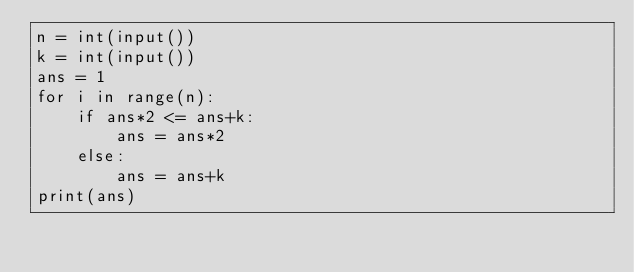<code> <loc_0><loc_0><loc_500><loc_500><_Python_>n = int(input())
k = int(input())
ans = 1
for i in range(n):
    if ans*2 <= ans+k:
        ans = ans*2
    else:
        ans = ans+k
print(ans)
</code> 